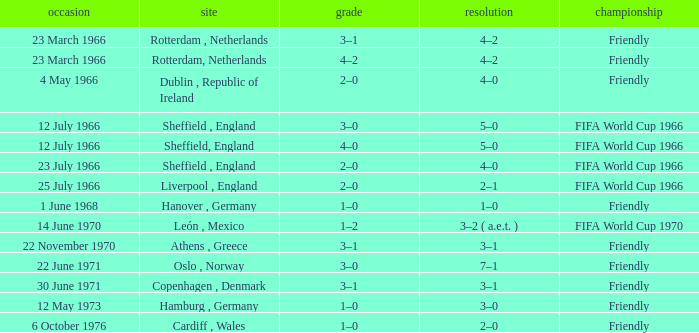Which result's venue was in Rotterdam, Netherlands? 4–2, 4–2. 